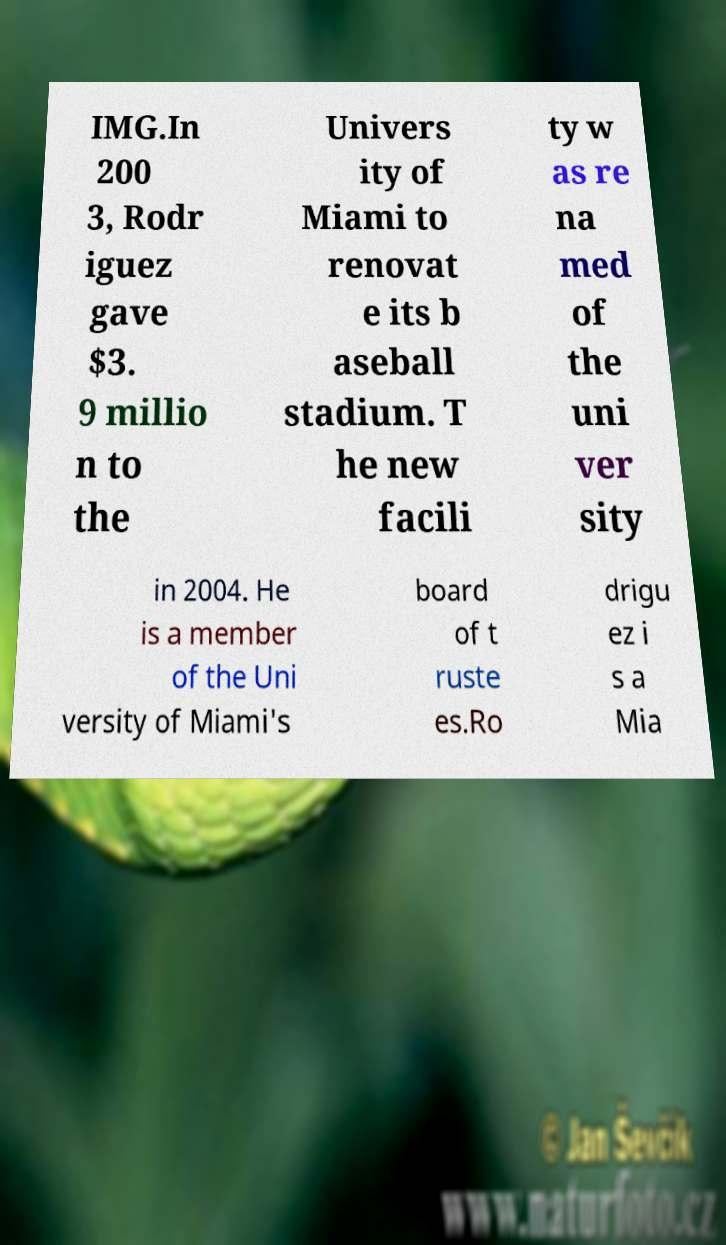Can you accurately transcribe the text from the provided image for me? IMG.In 200 3, Rodr iguez gave $3. 9 millio n to the Univers ity of Miami to renovat e its b aseball stadium. T he new facili ty w as re na med of the uni ver sity in 2004. He is a member of the Uni versity of Miami's board of t ruste es.Ro drigu ez i s a Mia 